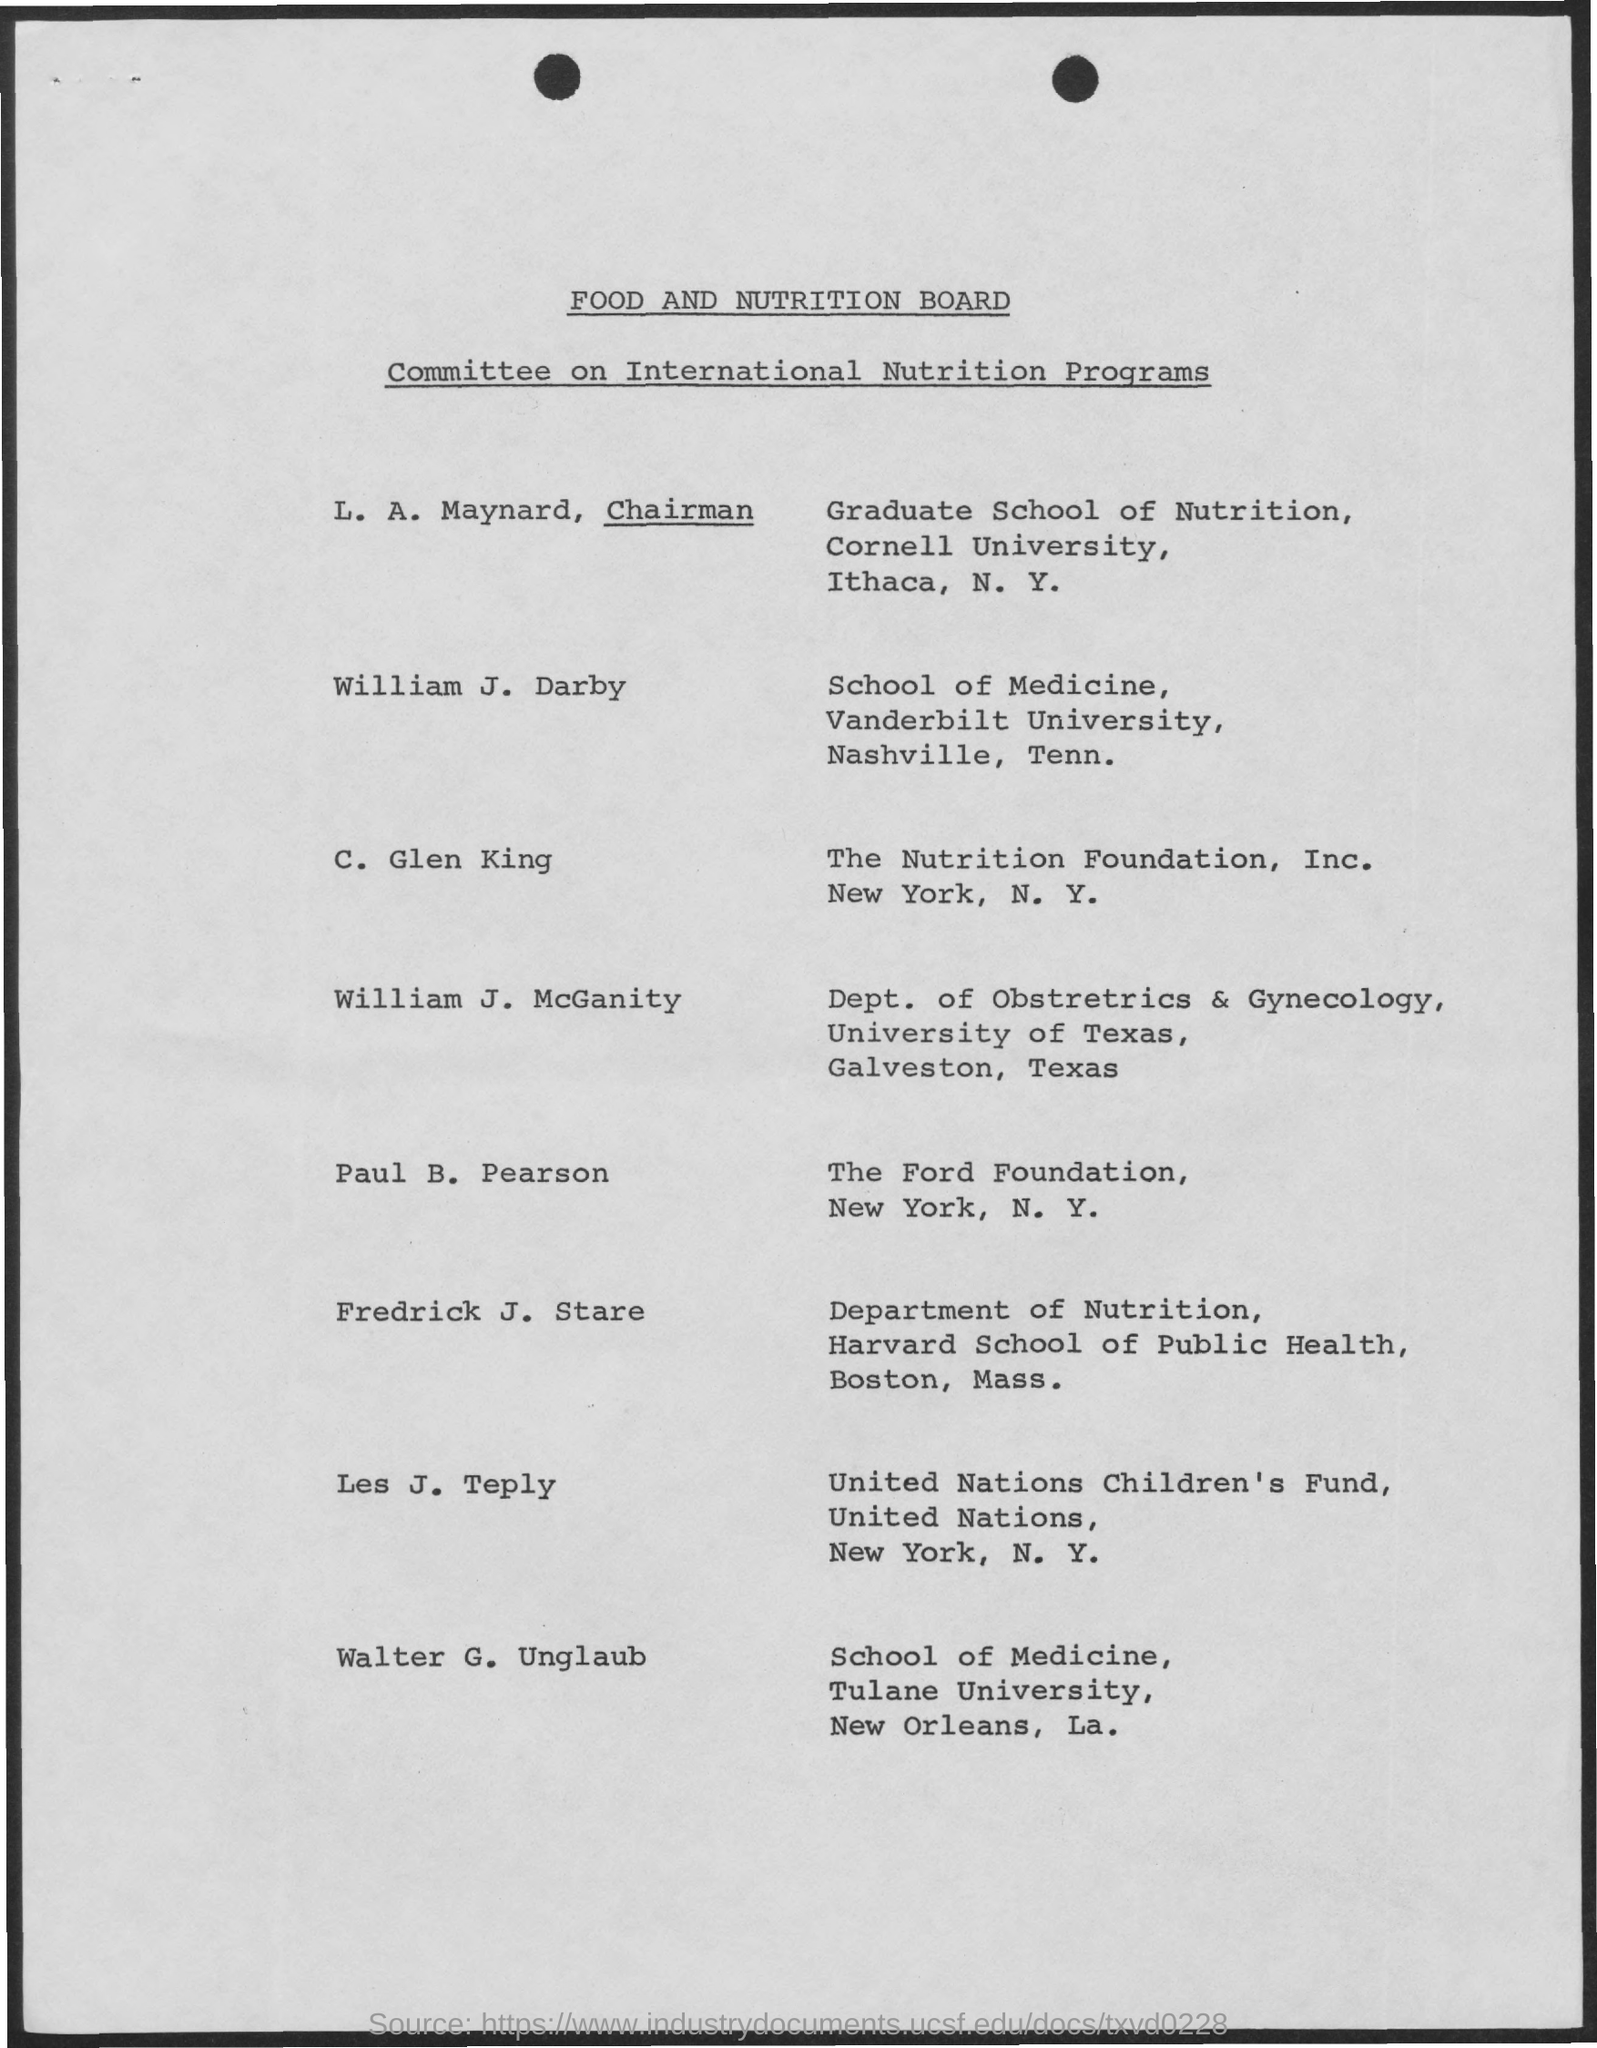Who is the chairman?
Provide a succinct answer. L. a. maynard. 